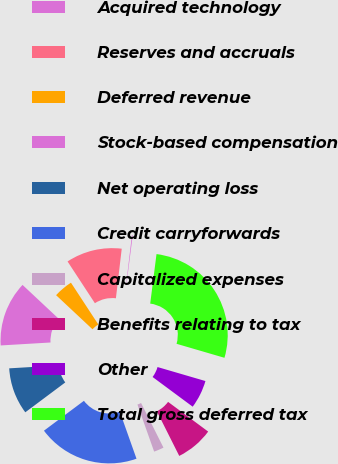Convert chart to OTSL. <chart><loc_0><loc_0><loc_500><loc_500><pie_chart><fcel>Acquired technology<fcel>Reserves and accruals<fcel>Deferred revenue<fcel>Stock-based compensation<fcel>Net operating loss<fcel>Credit carryforwards<fcel>Capitalized expenses<fcel>Benefits relating to tax<fcel>Other<fcel>Total gross deferred tax<nl><fcel>0.15%<fcel>11.09%<fcel>3.8%<fcel>12.92%<fcel>9.27%<fcel>20.21%<fcel>1.98%<fcel>7.45%<fcel>5.62%<fcel>27.51%<nl></chart> 